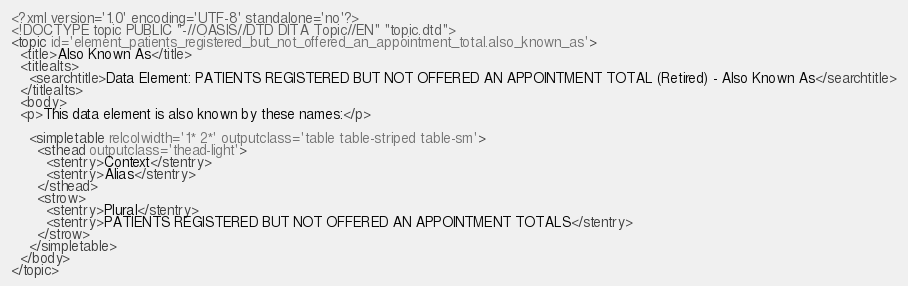Convert code to text. <code><loc_0><loc_0><loc_500><loc_500><_XML_><?xml version='1.0' encoding='UTF-8' standalone='no'?>
<!DOCTYPE topic PUBLIC "-//OASIS//DTD DITA Topic//EN" "topic.dtd">
<topic id='element_patients_registered_but_not_offered_an_appointment_total.also_known_as'>
  <title>Also Known As</title>
  <titlealts>
    <searchtitle>Data Element: PATIENTS REGISTERED BUT NOT OFFERED AN APPOINTMENT TOTAL (Retired) - Also Known As</searchtitle>
  </titlealts>
  <body>
  <p>This data element is also known by these names:</p>

    <simpletable relcolwidth='1* 2*' outputclass='table table-striped table-sm'>
      <sthead outputclass='thead-light'>
        <stentry>Context</stentry>
        <stentry>Alias</stentry>
      </sthead>
      <strow>
        <stentry>Plural</stentry>
        <stentry>PATIENTS REGISTERED BUT NOT OFFERED AN APPOINTMENT TOTALS</stentry>
      </strow>
    </simpletable>
  </body>
</topic></code> 